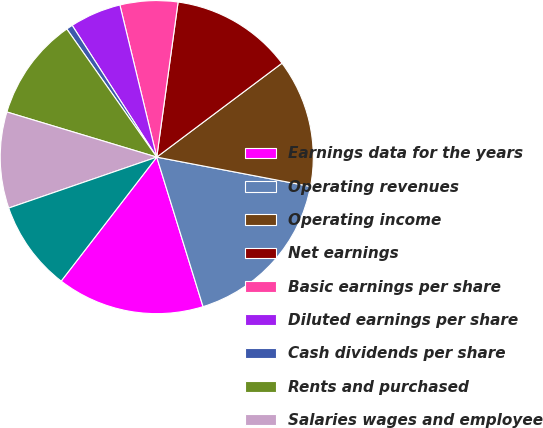Convert chart. <chart><loc_0><loc_0><loc_500><loc_500><pie_chart><fcel>Earnings data for the years<fcel>Operating revenues<fcel>Operating income<fcel>Net earnings<fcel>Basic earnings per share<fcel>Diluted earnings per share<fcel>Cash dividends per share<fcel>Rents and purchased<fcel>Salaries wages and employee<fcel>Fuel and fuel taxes<nl><fcel>15.23%<fcel>17.22%<fcel>13.24%<fcel>12.58%<fcel>5.96%<fcel>5.3%<fcel>0.66%<fcel>10.6%<fcel>9.93%<fcel>9.27%<nl></chart> 